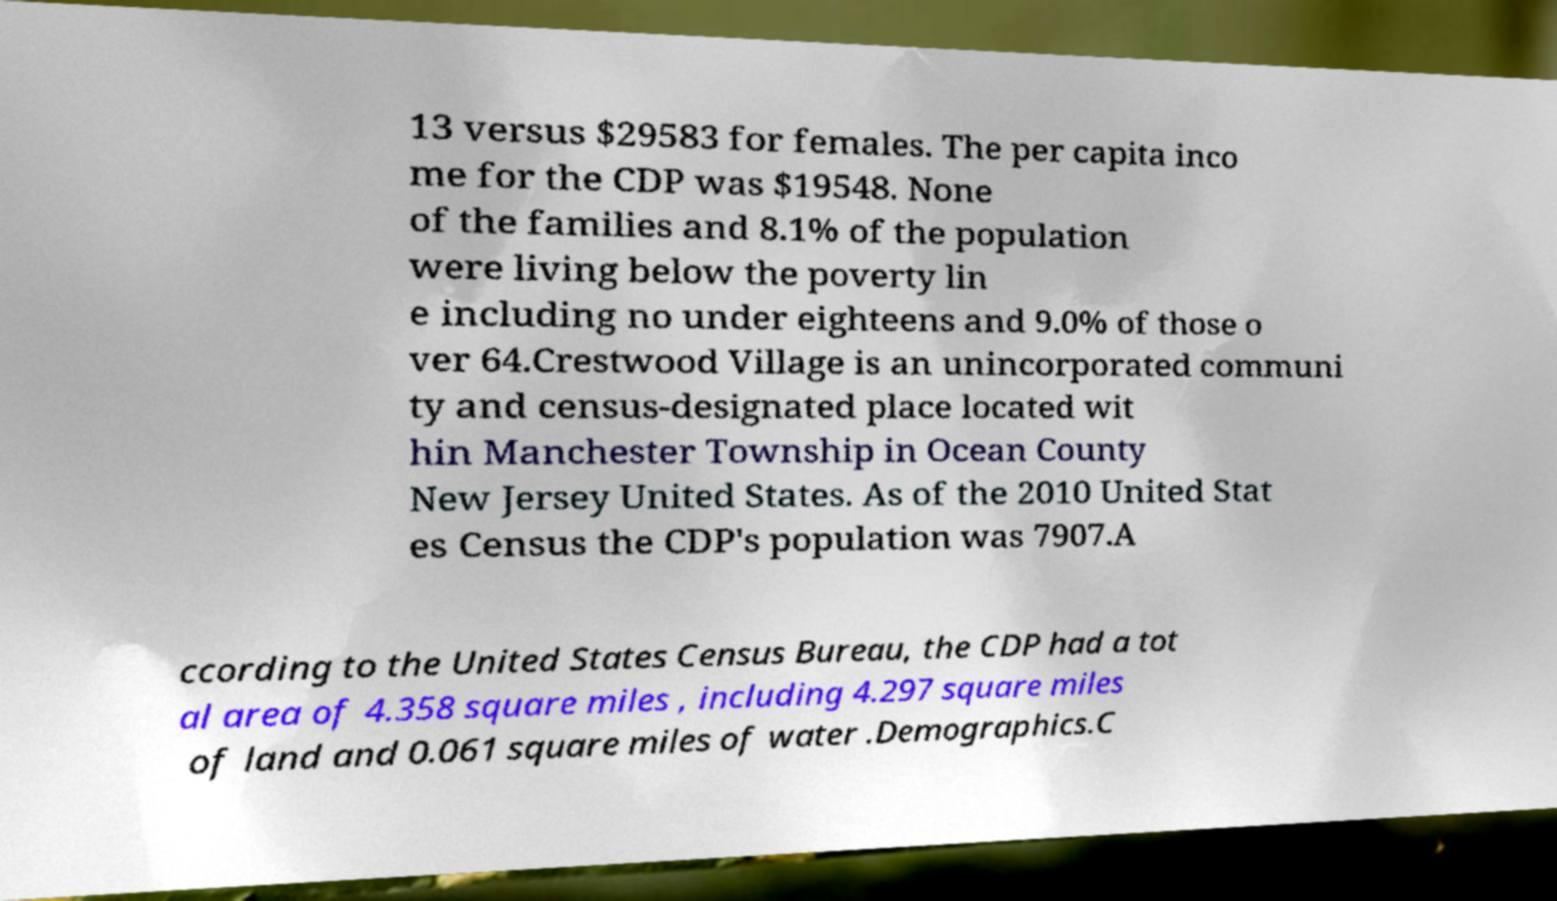There's text embedded in this image that I need extracted. Can you transcribe it verbatim? 13 versus $29583 for females. The per capita inco me for the CDP was $19548. None of the families and 8.1% of the population were living below the poverty lin e including no under eighteens and 9.0% of those o ver 64.Crestwood Village is an unincorporated communi ty and census-designated place located wit hin Manchester Township in Ocean County New Jersey United States. As of the 2010 United Stat es Census the CDP's population was 7907.A ccording to the United States Census Bureau, the CDP had a tot al area of 4.358 square miles , including 4.297 square miles of land and 0.061 square miles of water .Demographics.C 